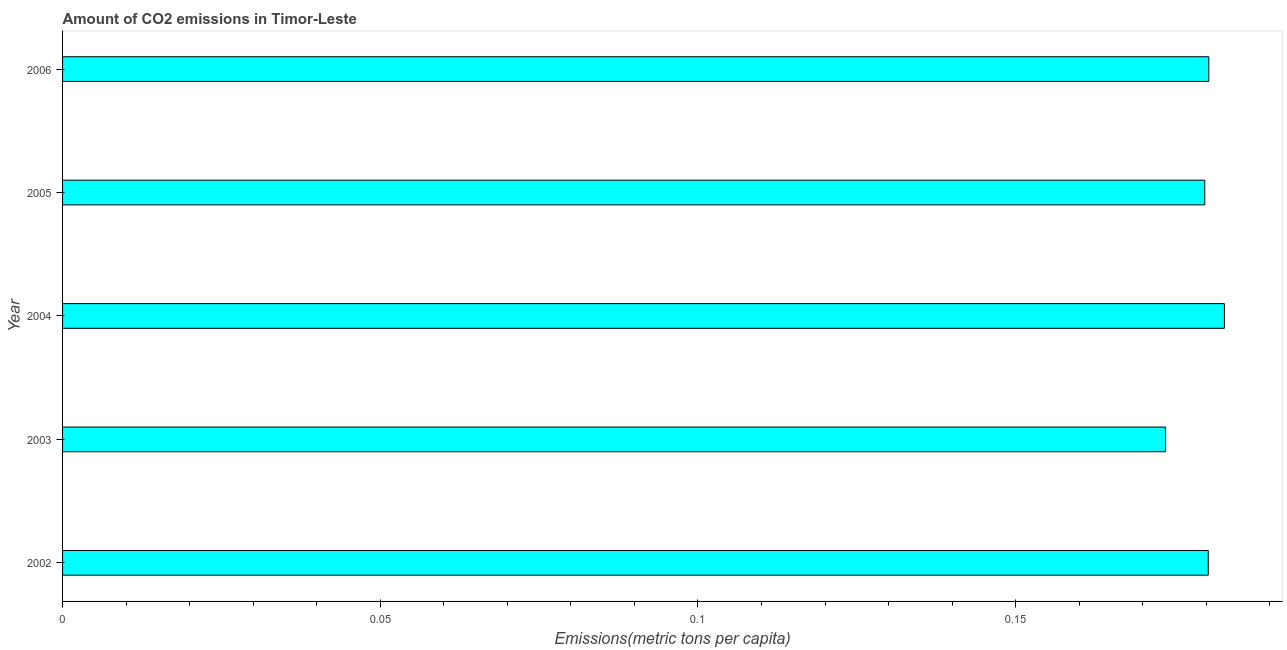Does the graph contain grids?
Offer a terse response. No. What is the title of the graph?
Offer a terse response. Amount of CO2 emissions in Timor-Leste. What is the label or title of the X-axis?
Make the answer very short. Emissions(metric tons per capita). What is the amount of co2 emissions in 2002?
Provide a short and direct response. 0.18. Across all years, what is the maximum amount of co2 emissions?
Ensure brevity in your answer.  0.18. Across all years, what is the minimum amount of co2 emissions?
Offer a very short reply. 0.17. In which year was the amount of co2 emissions maximum?
Offer a very short reply. 2004. What is the sum of the amount of co2 emissions?
Make the answer very short. 0.9. What is the difference between the amount of co2 emissions in 2003 and 2005?
Offer a terse response. -0.01. What is the average amount of co2 emissions per year?
Make the answer very short. 0.18. What is the median amount of co2 emissions?
Give a very brief answer. 0.18. Do a majority of the years between 2002 and 2005 (inclusive) have amount of co2 emissions greater than 0.06 metric tons per capita?
Offer a terse response. Yes. What is the difference between the highest and the second highest amount of co2 emissions?
Provide a succinct answer. 0. Is the sum of the amount of co2 emissions in 2005 and 2006 greater than the maximum amount of co2 emissions across all years?
Offer a terse response. Yes. What is the difference between the highest and the lowest amount of co2 emissions?
Your answer should be compact. 0.01. In how many years, is the amount of co2 emissions greater than the average amount of co2 emissions taken over all years?
Your answer should be compact. 4. How many bars are there?
Your answer should be compact. 5. How many years are there in the graph?
Offer a terse response. 5. What is the Emissions(metric tons per capita) in 2002?
Provide a short and direct response. 0.18. What is the Emissions(metric tons per capita) of 2003?
Provide a short and direct response. 0.17. What is the Emissions(metric tons per capita) of 2004?
Keep it short and to the point. 0.18. What is the Emissions(metric tons per capita) of 2005?
Offer a terse response. 0.18. What is the Emissions(metric tons per capita) in 2006?
Make the answer very short. 0.18. What is the difference between the Emissions(metric tons per capita) in 2002 and 2003?
Ensure brevity in your answer.  0.01. What is the difference between the Emissions(metric tons per capita) in 2002 and 2004?
Ensure brevity in your answer.  -0. What is the difference between the Emissions(metric tons per capita) in 2002 and 2005?
Keep it short and to the point. 0. What is the difference between the Emissions(metric tons per capita) in 2002 and 2006?
Offer a very short reply. -9e-5. What is the difference between the Emissions(metric tons per capita) in 2003 and 2004?
Ensure brevity in your answer.  -0.01. What is the difference between the Emissions(metric tons per capita) in 2003 and 2005?
Ensure brevity in your answer.  -0.01. What is the difference between the Emissions(metric tons per capita) in 2003 and 2006?
Provide a short and direct response. -0.01. What is the difference between the Emissions(metric tons per capita) in 2004 and 2005?
Make the answer very short. 0. What is the difference between the Emissions(metric tons per capita) in 2004 and 2006?
Make the answer very short. 0. What is the difference between the Emissions(metric tons per capita) in 2005 and 2006?
Provide a short and direct response. -0. What is the ratio of the Emissions(metric tons per capita) in 2002 to that in 2003?
Your answer should be very brief. 1.04. What is the ratio of the Emissions(metric tons per capita) in 2002 to that in 2006?
Offer a very short reply. 1. What is the ratio of the Emissions(metric tons per capita) in 2003 to that in 2004?
Your answer should be very brief. 0.95. What is the ratio of the Emissions(metric tons per capita) in 2003 to that in 2005?
Offer a very short reply. 0.97. What is the ratio of the Emissions(metric tons per capita) in 2003 to that in 2006?
Offer a very short reply. 0.96. What is the ratio of the Emissions(metric tons per capita) in 2005 to that in 2006?
Give a very brief answer. 1. 